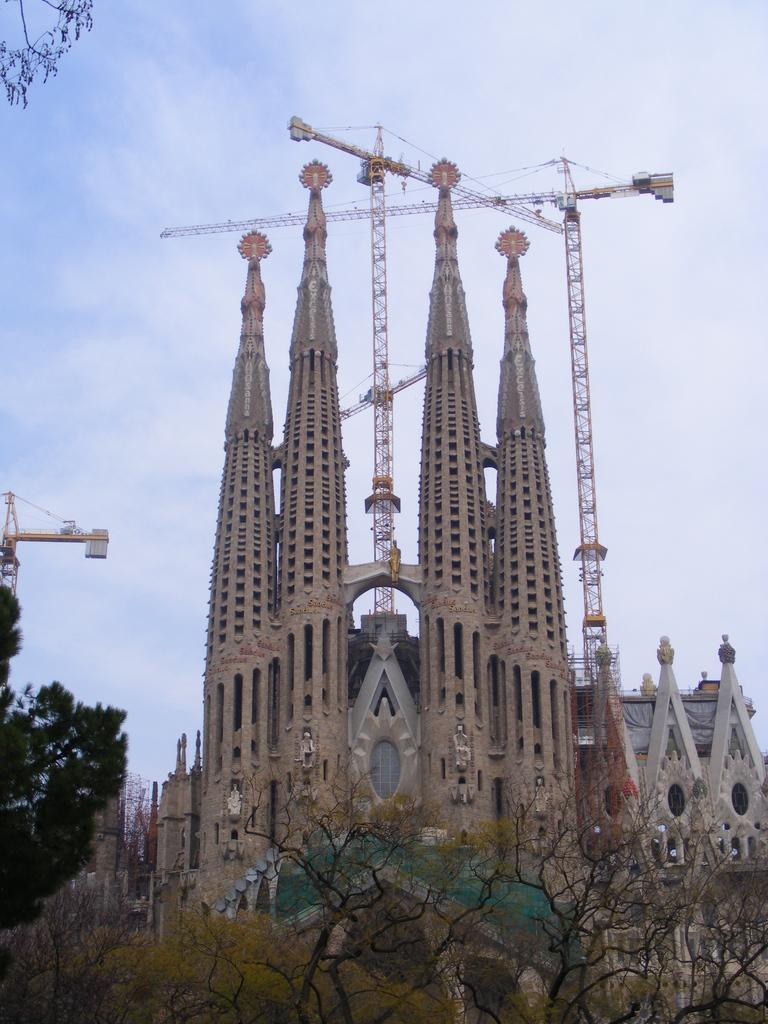What type of vegetation can be seen in the image? There are trees in the image. Where are the trees located in relation to the other elements in the image? The trees are in the foreground of the image. What structures can be seen in the background of the image? There are buildings in the background of the image. What else is visible in the background of the image? The sky is visible in the background of the image. What type of brick is used to construct the shelf in the image? There is no shelf or brick present in the image. 